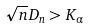Convert formula to latex. <formula><loc_0><loc_0><loc_500><loc_500>\sqrt { n } D _ { n } > K _ { \alpha }</formula> 